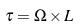<formula> <loc_0><loc_0><loc_500><loc_500>\tau = \Omega \times L</formula> 